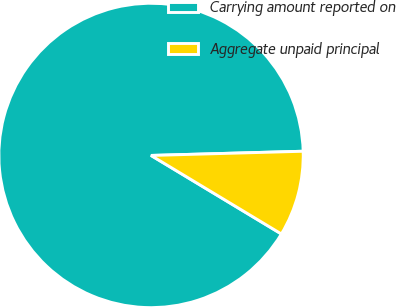<chart> <loc_0><loc_0><loc_500><loc_500><pie_chart><fcel>Carrying amount reported on<fcel>Aggregate unpaid principal<nl><fcel>90.93%<fcel>9.07%<nl></chart> 